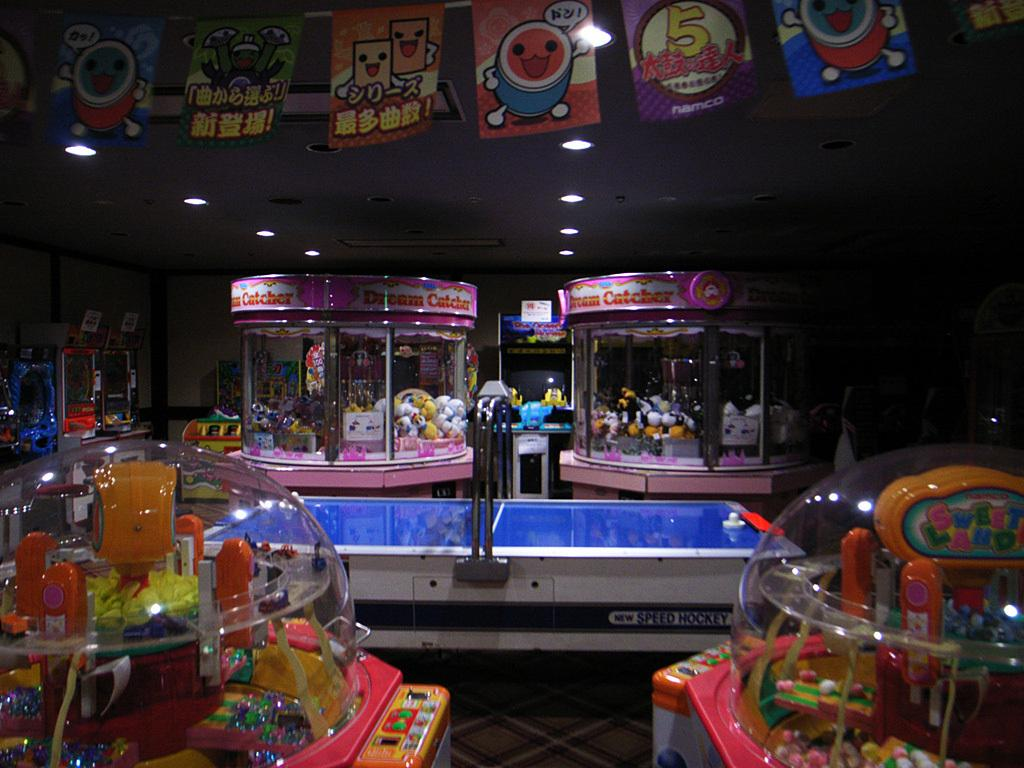What type of area is depicted in the image? The image depicts a game zone for kids. What can be found in this area for kids to play with? There are many games and toy machines in the area. Are there any decorations visible in the image? Yes, pictures are hanging from the ceiling. What can be seen in terms of lighting in the image? There are lights visible in the image. What is the tendency of the houses in the image? There are no houses present in the image; it depicts a game zone for kids. Can you tell me how many balls are visible in the image? There is no ball present in the image. 